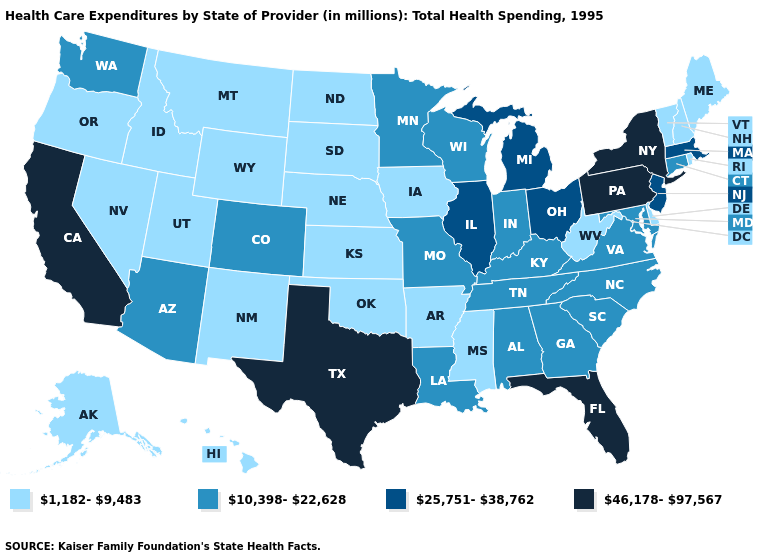Name the states that have a value in the range 1,182-9,483?
Concise answer only. Alaska, Arkansas, Delaware, Hawaii, Idaho, Iowa, Kansas, Maine, Mississippi, Montana, Nebraska, Nevada, New Hampshire, New Mexico, North Dakota, Oklahoma, Oregon, Rhode Island, South Dakota, Utah, Vermont, West Virginia, Wyoming. Which states have the lowest value in the USA?
Give a very brief answer. Alaska, Arkansas, Delaware, Hawaii, Idaho, Iowa, Kansas, Maine, Mississippi, Montana, Nebraska, Nevada, New Hampshire, New Mexico, North Dakota, Oklahoma, Oregon, Rhode Island, South Dakota, Utah, Vermont, West Virginia, Wyoming. Name the states that have a value in the range 25,751-38,762?
Be succinct. Illinois, Massachusetts, Michigan, New Jersey, Ohio. What is the highest value in states that border Colorado?
Give a very brief answer. 10,398-22,628. Among the states that border New Mexico , does Oklahoma have the lowest value?
Short answer required. Yes. Does Oregon have a lower value than Delaware?
Answer briefly. No. Which states have the lowest value in the South?
Keep it brief. Arkansas, Delaware, Mississippi, Oklahoma, West Virginia. What is the highest value in states that border North Dakota?
Concise answer only. 10,398-22,628. Does the first symbol in the legend represent the smallest category?
Be succinct. Yes. Among the states that border Connecticut , which have the lowest value?
Give a very brief answer. Rhode Island. Name the states that have a value in the range 46,178-97,567?
Quick response, please. California, Florida, New York, Pennsylvania, Texas. What is the lowest value in states that border Minnesota?
Short answer required. 1,182-9,483. Does New Hampshire have the lowest value in the USA?
Short answer required. Yes. What is the lowest value in the USA?
Short answer required. 1,182-9,483. What is the value of Michigan?
Answer briefly. 25,751-38,762. 